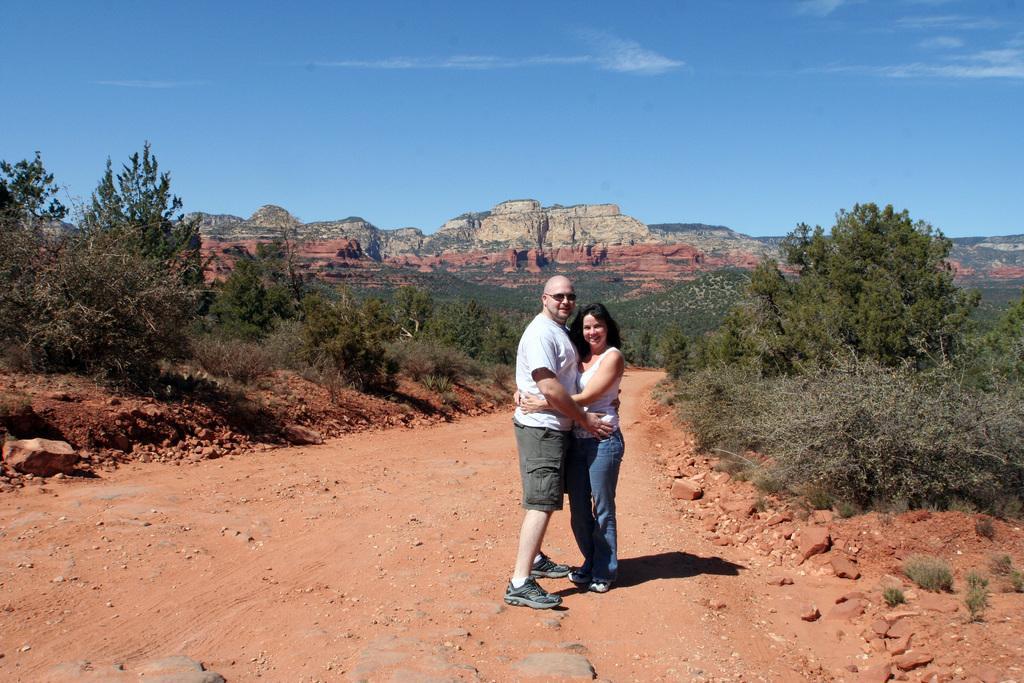Please provide a concise description of this image. In this image we can see two persons standing and smiling, there are some trees, plants, stones and hills, in the background we can see the sky with clouds. 